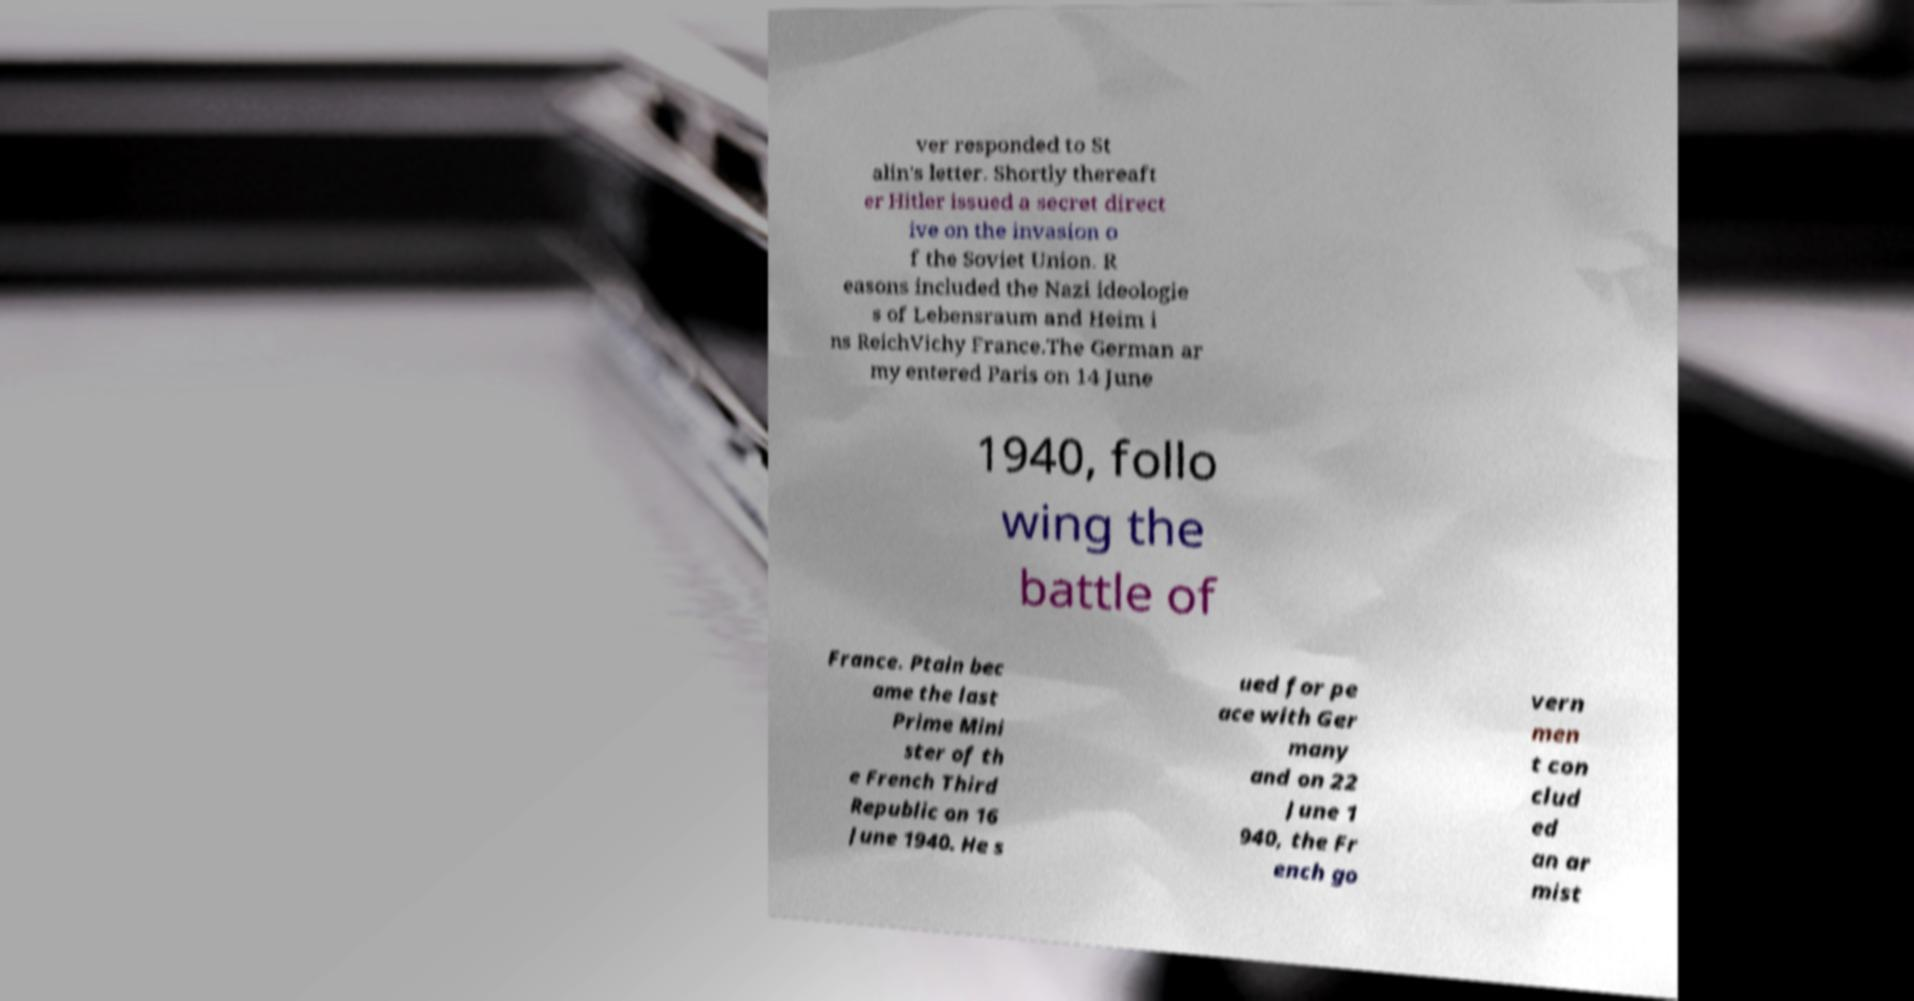Please read and relay the text visible in this image. What does it say? ver responded to St alin's letter. Shortly thereaft er Hitler issued a secret direct ive on the invasion o f the Soviet Union. R easons included the Nazi ideologie s of Lebensraum and Heim i ns ReichVichy France.The German ar my entered Paris on 14 June 1940, follo wing the battle of France. Ptain bec ame the last Prime Mini ster of th e French Third Republic on 16 June 1940. He s ued for pe ace with Ger many and on 22 June 1 940, the Fr ench go vern men t con clud ed an ar mist 